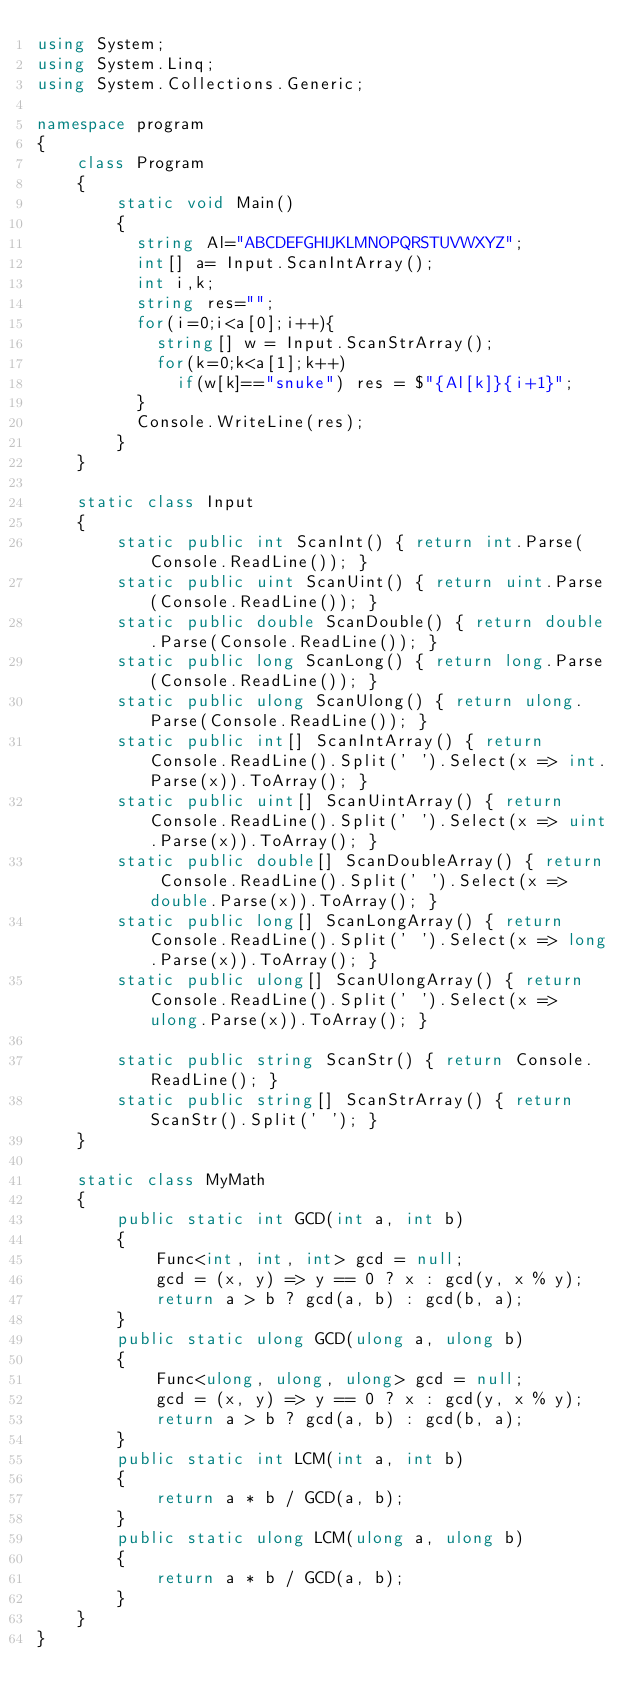Convert code to text. <code><loc_0><loc_0><loc_500><loc_500><_C#_>using System;
using System.Linq;
using System.Collections.Generic;

namespace program
{
    class Program
    {
        static void Main()
        {
          string Al="ABCDEFGHIJKLMNOPQRSTUVWXYZ";
          int[] a= Input.ScanIntArray();
          int i,k;
          string res="";
          for(i=0;i<a[0];i++){
            string[] w = Input.ScanStrArray();
            for(k=0;k<a[1];k++)
              if(w[k]=="snuke") res = $"{Al[k]}{i+1}";
          }
          Console.WriteLine(res);
        }
    }

    static class Input
    {
        static public int ScanInt() { return int.Parse(Console.ReadLine()); }
        static public uint ScanUint() { return uint.Parse(Console.ReadLine()); }
        static public double ScanDouble() { return double.Parse(Console.ReadLine()); }
        static public long ScanLong() { return long.Parse(Console.ReadLine()); }
        static public ulong ScanUlong() { return ulong.Parse(Console.ReadLine()); }
        static public int[] ScanIntArray() { return Console.ReadLine().Split(' ').Select(x => int.Parse(x)).ToArray(); }
        static public uint[] ScanUintArray() { return Console.ReadLine().Split(' ').Select(x => uint.Parse(x)).ToArray(); }
        static public double[] ScanDoubleArray() { return Console.ReadLine().Split(' ').Select(x => double.Parse(x)).ToArray(); }
        static public long[] ScanLongArray() { return Console.ReadLine().Split(' ').Select(x => long.Parse(x)).ToArray(); }
        static public ulong[] ScanUlongArray() { return Console.ReadLine().Split(' ').Select(x => ulong.Parse(x)).ToArray(); }

        static public string ScanStr() { return Console.ReadLine(); }
        static public string[] ScanStrArray() { return ScanStr().Split(' '); }
    }

    static class MyMath
    {
        public static int GCD(int a, int b)
        {
            Func<int, int, int> gcd = null;
            gcd = (x, y) => y == 0 ? x : gcd(y, x % y);
            return a > b ? gcd(a, b) : gcd(b, a);
        }
        public static ulong GCD(ulong a, ulong b)
        {
            Func<ulong, ulong, ulong> gcd = null;
            gcd = (x, y) => y == 0 ? x : gcd(y, x % y);
            return a > b ? gcd(a, b) : gcd(b, a);
        }
        public static int LCM(int a, int b)
        {
            return a * b / GCD(a, b);
        }
        public static ulong LCM(ulong a, ulong b)
        {
            return a * b / GCD(a, b);
        }
    }
}
</code> 